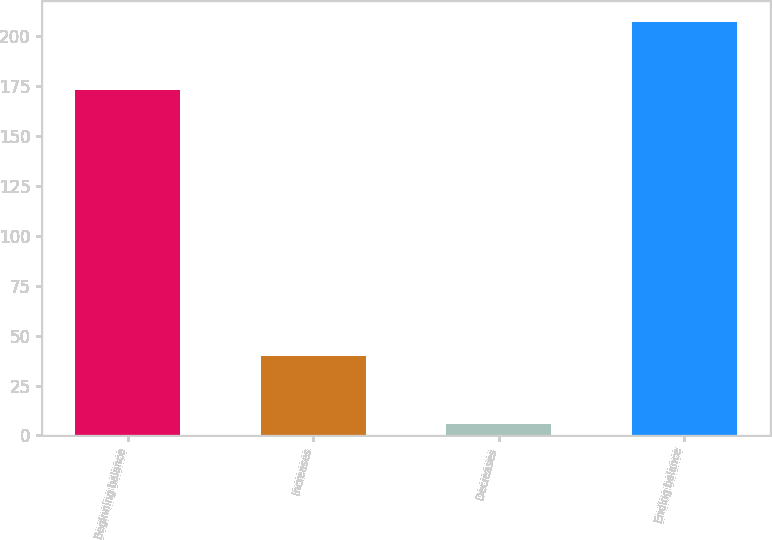Convert chart. <chart><loc_0><loc_0><loc_500><loc_500><bar_chart><fcel>Beginning balance<fcel>Increases<fcel>Decreases<fcel>Ending balance<nl><fcel>173<fcel>40<fcel>6<fcel>207<nl></chart> 